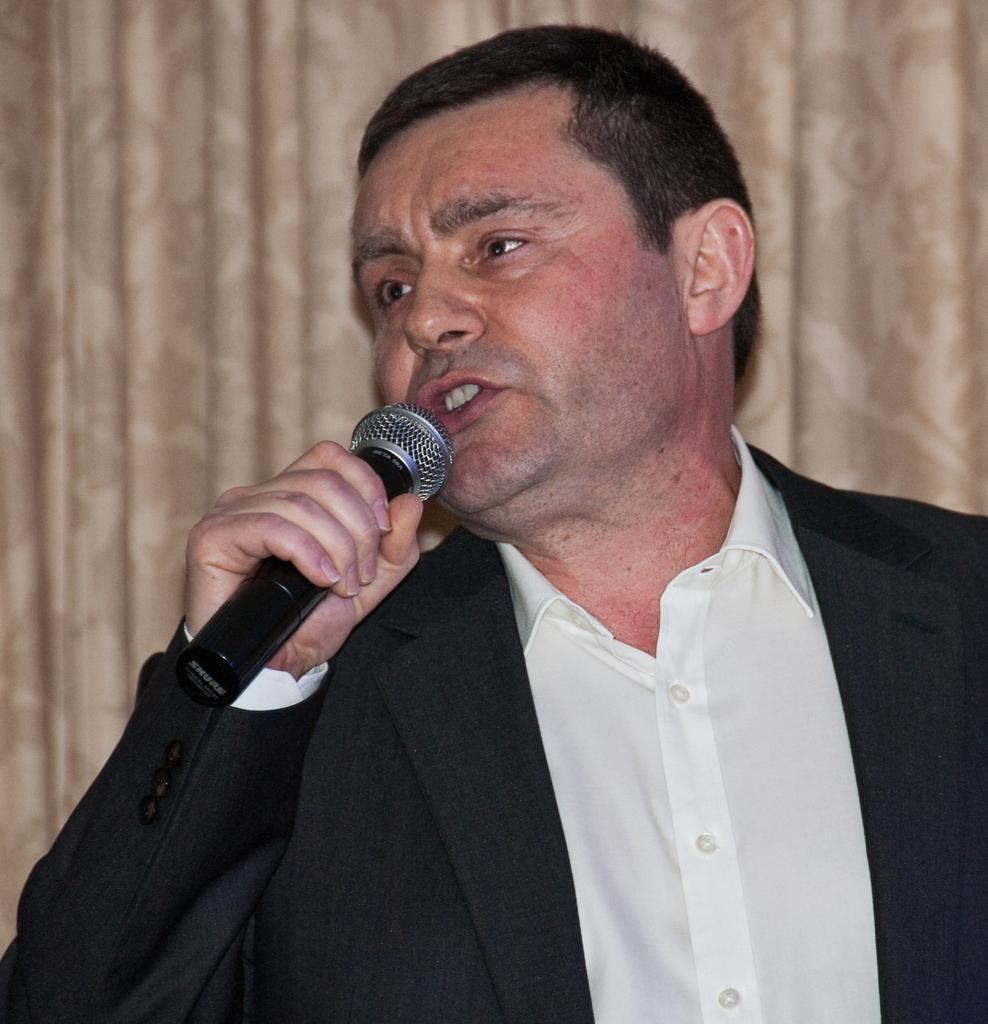What is the person in the image wearing? The person is wearing a suit and a shirt in the image. What is the person holding in the image? The person is holding a microphone in the image. What is the person doing in the image? The person is speaking in the image. What can be seen in the background of the image? There is a cream-colored curtain in the background of the image. What type of liquid is in the vase on the table in the image? There is no vase or table present in the image; it only features a person wearing a suit and a shirt, holding a microphone, and speaking. 